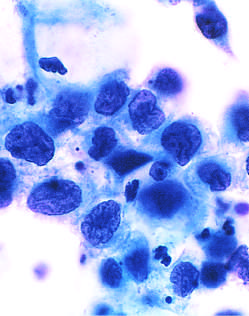does microscopic examination reflect the progressive loss of cellular differentiation on the surface of the cervical lesions from which these cells are exfoliated?
Answer the question using a single word or phrase. No 